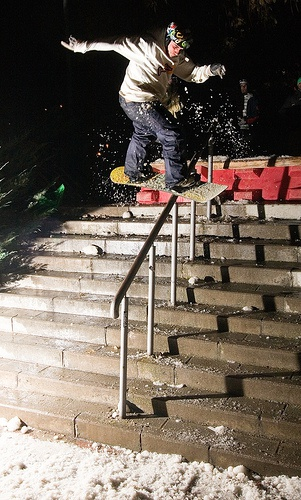Describe the objects in this image and their specific colors. I can see people in black, white, gray, and darkgray tones, snowboard in black and tan tones, people in black, gray, and darkgray tones, and people in black, maroon, and darkgreen tones in this image. 